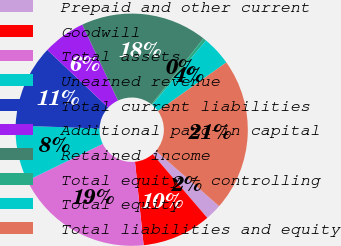Convert chart. <chart><loc_0><loc_0><loc_500><loc_500><pie_chart><fcel>Prepaid and other current<fcel>Goodwill<fcel>Total assets<fcel>Unearned revenue<fcel>Total current liabilities<fcel>Additional paid-in capital<fcel>Retained income<fcel>Total equity - controlling<fcel>Total equity<fcel>Total liabilities and equity<nl><fcel>2.29%<fcel>9.64%<fcel>19.42%<fcel>7.8%<fcel>11.48%<fcel>5.96%<fcel>17.58%<fcel>0.45%<fcel>4.12%<fcel>21.26%<nl></chart> 